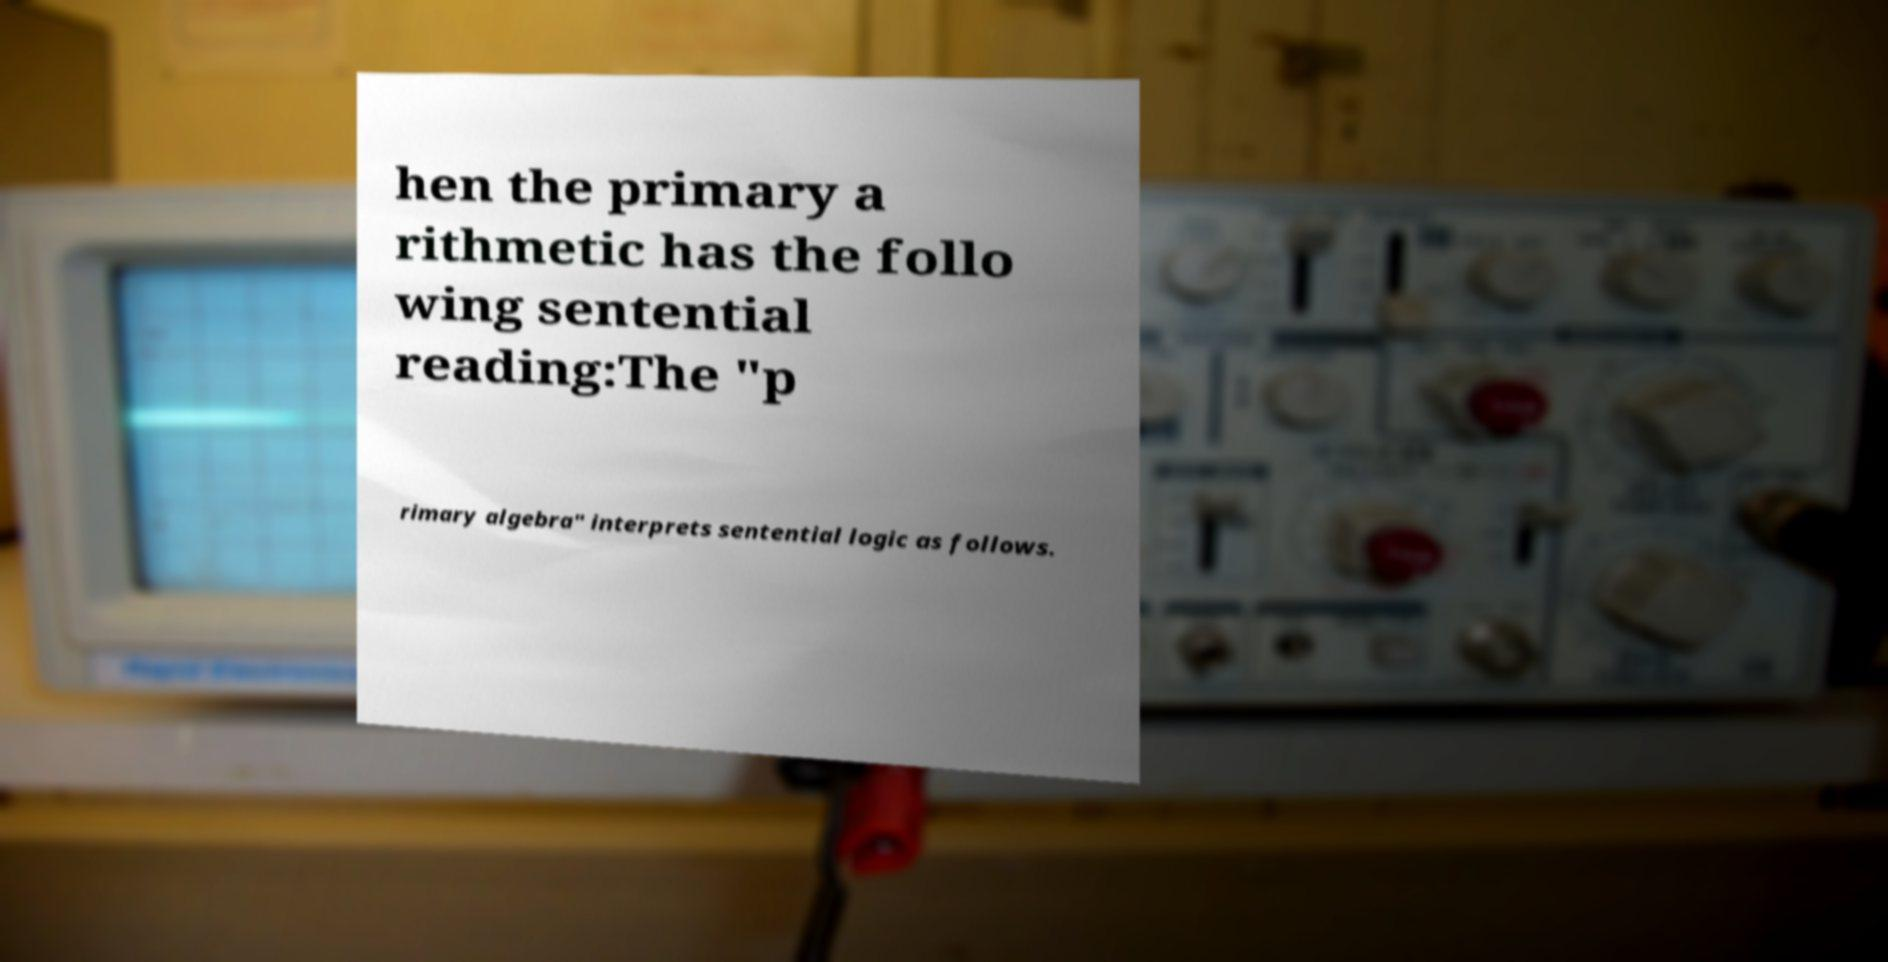Could you assist in decoding the text presented in this image and type it out clearly? hen the primary a rithmetic has the follo wing sentential reading:The "p rimary algebra" interprets sentential logic as follows. 